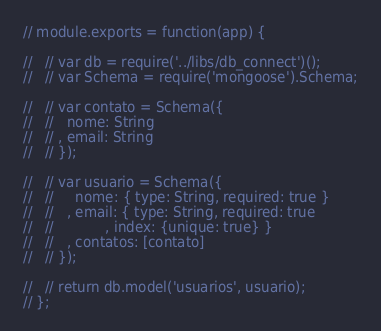<code> <loc_0><loc_0><loc_500><loc_500><_JavaScript_>// module.exports = function(app) {

//   // var db = require('../libs/db_connect')();
//   // var Schema = require('mongoose').Schema;

//   // var contato = Schema({
//   //   nome: String
//   // , email: String
//   // });

//   // var usuario = Schema({
//   //     nome: { type: String, required: true }
//   //   , email: { type: String, required: true
//   //            , index: {unique: true} }
//   //   , contatos: [contato]
//   // });

//   // return db.model('usuarios', usuario);
// };</code> 